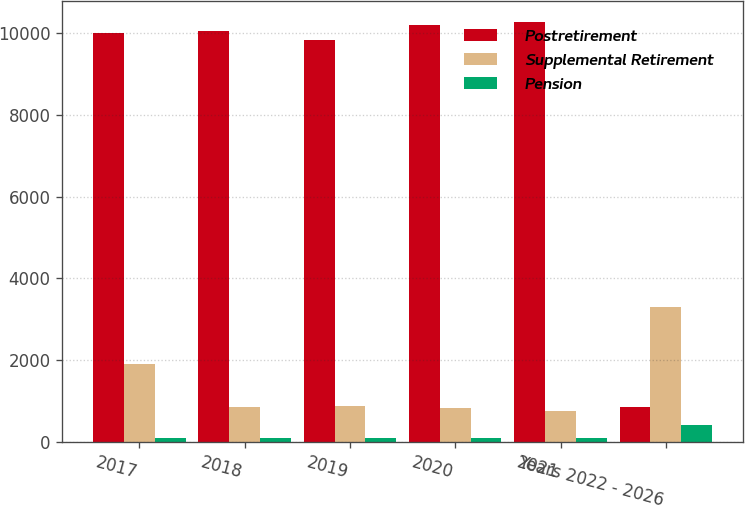Convert chart. <chart><loc_0><loc_0><loc_500><loc_500><stacked_bar_chart><ecel><fcel>2017<fcel>2018<fcel>2019<fcel>2020<fcel>2021<fcel>Years 2022 - 2026<nl><fcel>Postretirement<fcel>9988<fcel>10051<fcel>9821<fcel>10181<fcel>10268<fcel>855<nl><fcel>Supplemental Retirement<fcel>1911<fcel>855<fcel>882<fcel>834<fcel>766<fcel>3309<nl><fcel>Pension<fcel>94<fcel>99<fcel>100<fcel>103<fcel>98<fcel>419<nl></chart> 